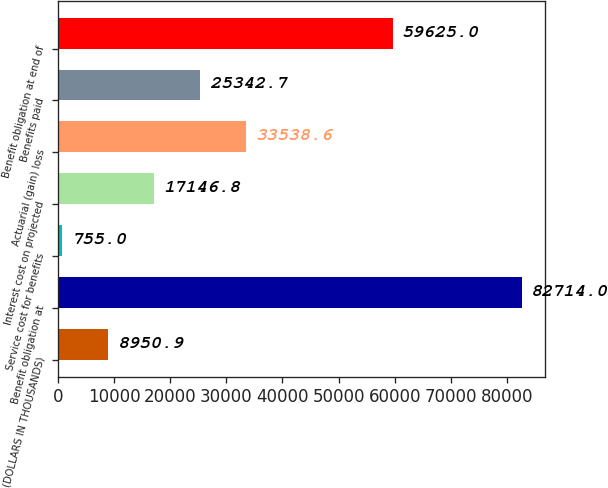Convert chart to OTSL. <chart><loc_0><loc_0><loc_500><loc_500><bar_chart><fcel>(DOLLARS IN THOUSANDS)<fcel>Benefit obligation at<fcel>Service cost for benefits<fcel>Interest cost on projected<fcel>Actuarial (gain) loss<fcel>Benefits paid<fcel>Benefit obligation at end of<nl><fcel>8950.9<fcel>82714<fcel>755<fcel>17146.8<fcel>33538.6<fcel>25342.7<fcel>59625<nl></chart> 